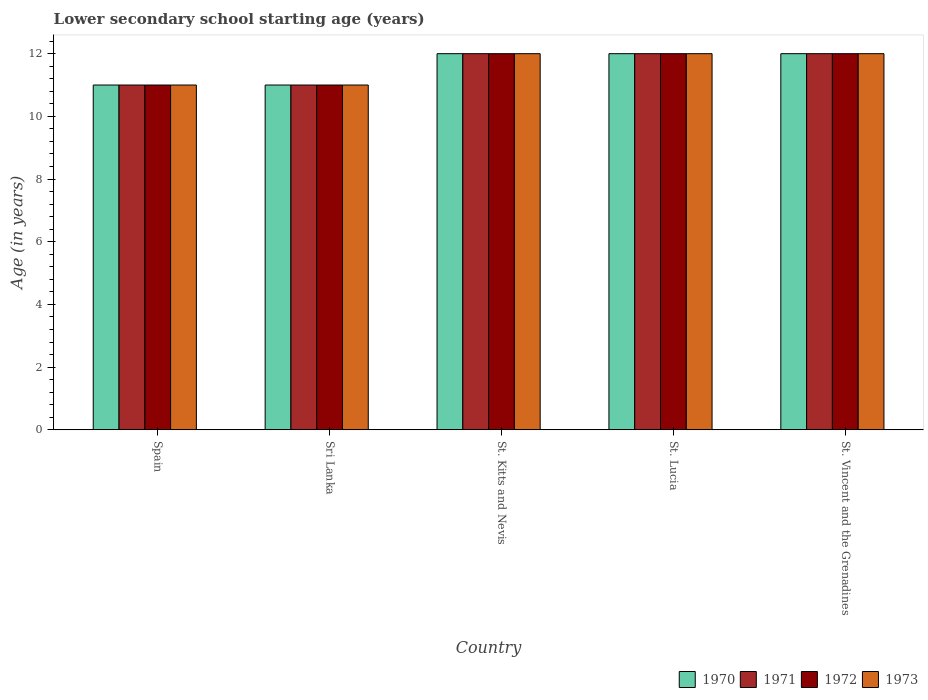How many different coloured bars are there?
Give a very brief answer. 4. How many groups of bars are there?
Offer a very short reply. 5. Are the number of bars on each tick of the X-axis equal?
Your answer should be very brief. Yes. What is the lower secondary school starting age of children in 1971 in St. Lucia?
Make the answer very short. 12. Across all countries, what is the minimum lower secondary school starting age of children in 1971?
Your answer should be very brief. 11. In which country was the lower secondary school starting age of children in 1973 maximum?
Keep it short and to the point. St. Kitts and Nevis. In which country was the lower secondary school starting age of children in 1973 minimum?
Make the answer very short. Spain. What is the difference between the lower secondary school starting age of children in 1970 in St. Kitts and Nevis and the lower secondary school starting age of children in 1971 in Sri Lanka?
Keep it short and to the point. 1. What is the average lower secondary school starting age of children in 1972 per country?
Offer a terse response. 11.6. What is the difference between the lower secondary school starting age of children of/in 1973 and lower secondary school starting age of children of/in 1971 in Spain?
Your answer should be very brief. 0. In how many countries, is the lower secondary school starting age of children in 1970 greater than 10.4 years?
Your answer should be compact. 5. What is the ratio of the lower secondary school starting age of children in 1972 in Spain to that in St. Lucia?
Provide a succinct answer. 0.92. Is the lower secondary school starting age of children in 1972 in Spain less than that in St. Kitts and Nevis?
Give a very brief answer. Yes. What is the difference between the highest and the lowest lower secondary school starting age of children in 1973?
Your response must be concise. 1. In how many countries, is the lower secondary school starting age of children in 1971 greater than the average lower secondary school starting age of children in 1971 taken over all countries?
Ensure brevity in your answer.  3. Is the sum of the lower secondary school starting age of children in 1971 in Sri Lanka and St. Lucia greater than the maximum lower secondary school starting age of children in 1973 across all countries?
Keep it short and to the point. Yes. What does the 4th bar from the right in St. Kitts and Nevis represents?
Give a very brief answer. 1970. Is it the case that in every country, the sum of the lower secondary school starting age of children in 1971 and lower secondary school starting age of children in 1972 is greater than the lower secondary school starting age of children in 1973?
Offer a very short reply. Yes. How many bars are there?
Your response must be concise. 20. Are the values on the major ticks of Y-axis written in scientific E-notation?
Make the answer very short. No. Does the graph contain any zero values?
Your answer should be compact. No. Does the graph contain grids?
Your response must be concise. No. Where does the legend appear in the graph?
Your answer should be very brief. Bottom right. What is the title of the graph?
Ensure brevity in your answer.  Lower secondary school starting age (years). Does "2013" appear as one of the legend labels in the graph?
Your answer should be compact. No. What is the label or title of the Y-axis?
Your answer should be compact. Age (in years). What is the Age (in years) of 1971 in Spain?
Give a very brief answer. 11. What is the Age (in years) of 1973 in Spain?
Offer a terse response. 11. What is the Age (in years) of 1971 in Sri Lanka?
Keep it short and to the point. 11. What is the Age (in years) of 1973 in St. Kitts and Nevis?
Your answer should be compact. 12. What is the Age (in years) of 1970 in St. Lucia?
Your response must be concise. 12. What is the Age (in years) in 1971 in St. Lucia?
Ensure brevity in your answer.  12. What is the Age (in years) in 1973 in St. Lucia?
Offer a very short reply. 12. What is the Age (in years) of 1970 in St. Vincent and the Grenadines?
Provide a short and direct response. 12. What is the Age (in years) in 1971 in St. Vincent and the Grenadines?
Ensure brevity in your answer.  12. What is the Age (in years) of 1972 in St. Vincent and the Grenadines?
Ensure brevity in your answer.  12. Across all countries, what is the maximum Age (in years) of 1972?
Offer a very short reply. 12. Across all countries, what is the maximum Age (in years) in 1973?
Offer a very short reply. 12. Across all countries, what is the minimum Age (in years) of 1971?
Your response must be concise. 11. What is the difference between the Age (in years) in 1970 in Spain and that in Sri Lanka?
Make the answer very short. 0. What is the difference between the Age (in years) of 1971 in Spain and that in Sri Lanka?
Provide a succinct answer. 0. What is the difference between the Age (in years) in 1972 in Spain and that in Sri Lanka?
Keep it short and to the point. 0. What is the difference between the Age (in years) in 1971 in Spain and that in St. Kitts and Nevis?
Provide a short and direct response. -1. What is the difference between the Age (in years) of 1972 in Spain and that in St. Kitts and Nevis?
Offer a terse response. -1. What is the difference between the Age (in years) in 1973 in Spain and that in St. Kitts and Nevis?
Your answer should be compact. -1. What is the difference between the Age (in years) of 1970 in Spain and that in St. Lucia?
Offer a terse response. -1. What is the difference between the Age (in years) of 1971 in Spain and that in St. Lucia?
Give a very brief answer. -1. What is the difference between the Age (in years) in 1972 in Spain and that in St. Lucia?
Offer a very short reply. -1. What is the difference between the Age (in years) in 1970 in Spain and that in St. Vincent and the Grenadines?
Your answer should be very brief. -1. What is the difference between the Age (in years) in 1970 in Sri Lanka and that in St. Kitts and Nevis?
Your answer should be very brief. -1. What is the difference between the Age (in years) of 1972 in Sri Lanka and that in St. Kitts and Nevis?
Make the answer very short. -1. What is the difference between the Age (in years) in 1971 in Sri Lanka and that in St. Lucia?
Offer a terse response. -1. What is the difference between the Age (in years) of 1972 in Sri Lanka and that in St. Lucia?
Your answer should be very brief. -1. What is the difference between the Age (in years) of 1971 in Sri Lanka and that in St. Vincent and the Grenadines?
Your answer should be very brief. -1. What is the difference between the Age (in years) in 1972 in Sri Lanka and that in St. Vincent and the Grenadines?
Keep it short and to the point. -1. What is the difference between the Age (in years) in 1973 in Sri Lanka and that in St. Vincent and the Grenadines?
Keep it short and to the point. -1. What is the difference between the Age (in years) of 1971 in St. Kitts and Nevis and that in St. Lucia?
Your response must be concise. 0. What is the difference between the Age (in years) of 1970 in St. Kitts and Nevis and that in St. Vincent and the Grenadines?
Provide a succinct answer. 0. What is the difference between the Age (in years) in 1971 in St. Kitts and Nevis and that in St. Vincent and the Grenadines?
Your answer should be compact. 0. What is the difference between the Age (in years) in 1972 in St. Kitts and Nevis and that in St. Vincent and the Grenadines?
Make the answer very short. 0. What is the difference between the Age (in years) of 1971 in St. Lucia and that in St. Vincent and the Grenadines?
Ensure brevity in your answer.  0. What is the difference between the Age (in years) in 1972 in St. Lucia and that in St. Vincent and the Grenadines?
Ensure brevity in your answer.  0. What is the difference between the Age (in years) of 1973 in St. Lucia and that in St. Vincent and the Grenadines?
Your answer should be compact. 0. What is the difference between the Age (in years) of 1970 in Spain and the Age (in years) of 1971 in Sri Lanka?
Keep it short and to the point. 0. What is the difference between the Age (in years) in 1970 in Spain and the Age (in years) in 1972 in Sri Lanka?
Ensure brevity in your answer.  0. What is the difference between the Age (in years) of 1970 in Spain and the Age (in years) of 1971 in St. Kitts and Nevis?
Keep it short and to the point. -1. What is the difference between the Age (in years) of 1970 in Spain and the Age (in years) of 1972 in St. Kitts and Nevis?
Give a very brief answer. -1. What is the difference between the Age (in years) of 1970 in Spain and the Age (in years) of 1973 in St. Kitts and Nevis?
Your answer should be very brief. -1. What is the difference between the Age (in years) in 1971 in Spain and the Age (in years) in 1972 in St. Kitts and Nevis?
Offer a terse response. -1. What is the difference between the Age (in years) of 1972 in Spain and the Age (in years) of 1973 in St. Kitts and Nevis?
Provide a succinct answer. -1. What is the difference between the Age (in years) of 1970 in Spain and the Age (in years) of 1972 in St. Lucia?
Provide a succinct answer. -1. What is the difference between the Age (in years) in 1971 in Spain and the Age (in years) in 1972 in St. Lucia?
Offer a terse response. -1. What is the difference between the Age (in years) in 1971 in Spain and the Age (in years) in 1973 in St. Lucia?
Give a very brief answer. -1. What is the difference between the Age (in years) in 1972 in Spain and the Age (in years) in 1973 in St. Lucia?
Keep it short and to the point. -1. What is the difference between the Age (in years) of 1970 in Spain and the Age (in years) of 1972 in St. Vincent and the Grenadines?
Offer a very short reply. -1. What is the difference between the Age (in years) in 1970 in Spain and the Age (in years) in 1973 in St. Vincent and the Grenadines?
Give a very brief answer. -1. What is the difference between the Age (in years) in 1971 in Sri Lanka and the Age (in years) in 1973 in St. Kitts and Nevis?
Offer a terse response. -1. What is the difference between the Age (in years) of 1970 in Sri Lanka and the Age (in years) of 1971 in St. Lucia?
Provide a succinct answer. -1. What is the difference between the Age (in years) in 1970 in Sri Lanka and the Age (in years) in 1972 in St. Lucia?
Provide a short and direct response. -1. What is the difference between the Age (in years) of 1971 in Sri Lanka and the Age (in years) of 1972 in St. Lucia?
Your answer should be compact. -1. What is the difference between the Age (in years) in 1970 in Sri Lanka and the Age (in years) in 1971 in St. Vincent and the Grenadines?
Your answer should be compact. -1. What is the difference between the Age (in years) of 1970 in Sri Lanka and the Age (in years) of 1973 in St. Vincent and the Grenadines?
Your answer should be compact. -1. What is the difference between the Age (in years) of 1971 in Sri Lanka and the Age (in years) of 1973 in St. Vincent and the Grenadines?
Provide a succinct answer. -1. What is the difference between the Age (in years) of 1972 in Sri Lanka and the Age (in years) of 1973 in St. Vincent and the Grenadines?
Offer a terse response. -1. What is the difference between the Age (in years) of 1970 in St. Kitts and Nevis and the Age (in years) of 1971 in St. Lucia?
Offer a terse response. 0. What is the difference between the Age (in years) of 1970 in St. Kitts and Nevis and the Age (in years) of 1972 in St. Lucia?
Give a very brief answer. 0. What is the difference between the Age (in years) in 1970 in St. Kitts and Nevis and the Age (in years) in 1973 in St. Lucia?
Ensure brevity in your answer.  0. What is the difference between the Age (in years) in 1971 in St. Kitts and Nevis and the Age (in years) in 1973 in St. Lucia?
Provide a succinct answer. 0. What is the difference between the Age (in years) in 1970 in St. Kitts and Nevis and the Age (in years) in 1971 in St. Vincent and the Grenadines?
Ensure brevity in your answer.  0. What is the difference between the Age (in years) of 1970 in St. Kitts and Nevis and the Age (in years) of 1973 in St. Vincent and the Grenadines?
Provide a succinct answer. 0. What is the difference between the Age (in years) in 1971 in St. Kitts and Nevis and the Age (in years) in 1973 in St. Vincent and the Grenadines?
Keep it short and to the point. 0. What is the difference between the Age (in years) of 1970 in St. Lucia and the Age (in years) of 1971 in St. Vincent and the Grenadines?
Ensure brevity in your answer.  0. What is the difference between the Age (in years) of 1970 in St. Lucia and the Age (in years) of 1972 in St. Vincent and the Grenadines?
Your answer should be very brief. 0. What is the difference between the Age (in years) of 1971 in St. Lucia and the Age (in years) of 1973 in St. Vincent and the Grenadines?
Provide a succinct answer. 0. What is the average Age (in years) of 1970 per country?
Keep it short and to the point. 11.6. What is the average Age (in years) in 1971 per country?
Provide a short and direct response. 11.6. What is the average Age (in years) in 1972 per country?
Your answer should be compact. 11.6. What is the average Age (in years) of 1973 per country?
Offer a very short reply. 11.6. What is the difference between the Age (in years) in 1970 and Age (in years) in 1972 in Spain?
Give a very brief answer. 0. What is the difference between the Age (in years) of 1970 and Age (in years) of 1971 in Sri Lanka?
Provide a succinct answer. 0. What is the difference between the Age (in years) of 1971 and Age (in years) of 1973 in Sri Lanka?
Your response must be concise. 0. What is the difference between the Age (in years) of 1970 and Age (in years) of 1972 in St. Kitts and Nevis?
Provide a succinct answer. 0. What is the difference between the Age (in years) of 1971 and Age (in years) of 1973 in St. Kitts and Nevis?
Offer a very short reply. 0. What is the difference between the Age (in years) in 1970 and Age (in years) in 1971 in St. Lucia?
Provide a succinct answer. 0. What is the difference between the Age (in years) of 1971 and Age (in years) of 1972 in St. Lucia?
Offer a very short reply. 0. What is the difference between the Age (in years) in 1972 and Age (in years) in 1973 in St. Lucia?
Your response must be concise. 0. What is the difference between the Age (in years) of 1972 and Age (in years) of 1973 in St. Vincent and the Grenadines?
Your response must be concise. 0. What is the ratio of the Age (in years) in 1971 in Spain to that in Sri Lanka?
Keep it short and to the point. 1. What is the ratio of the Age (in years) of 1972 in Spain to that in Sri Lanka?
Offer a terse response. 1. What is the ratio of the Age (in years) in 1970 in Spain to that in St. Kitts and Nevis?
Make the answer very short. 0.92. What is the ratio of the Age (in years) in 1971 in Spain to that in St. Kitts and Nevis?
Offer a very short reply. 0.92. What is the ratio of the Age (in years) of 1970 in Spain to that in St. Lucia?
Keep it short and to the point. 0.92. What is the ratio of the Age (in years) of 1972 in Spain to that in St. Lucia?
Your response must be concise. 0.92. What is the ratio of the Age (in years) of 1970 in Spain to that in St. Vincent and the Grenadines?
Your answer should be very brief. 0.92. What is the ratio of the Age (in years) of 1971 in Spain to that in St. Vincent and the Grenadines?
Offer a terse response. 0.92. What is the ratio of the Age (in years) of 1973 in Spain to that in St. Vincent and the Grenadines?
Offer a terse response. 0.92. What is the ratio of the Age (in years) in 1972 in Sri Lanka to that in St. Lucia?
Your answer should be compact. 0.92. What is the ratio of the Age (in years) of 1970 in Sri Lanka to that in St. Vincent and the Grenadines?
Your response must be concise. 0.92. What is the ratio of the Age (in years) of 1972 in Sri Lanka to that in St. Vincent and the Grenadines?
Make the answer very short. 0.92. What is the ratio of the Age (in years) in 1973 in Sri Lanka to that in St. Vincent and the Grenadines?
Provide a succinct answer. 0.92. What is the ratio of the Age (in years) of 1970 in St. Kitts and Nevis to that in St. Lucia?
Your answer should be compact. 1. What is the ratio of the Age (in years) in 1971 in St. Kitts and Nevis to that in St. Lucia?
Offer a very short reply. 1. What is the ratio of the Age (in years) of 1973 in St. Kitts and Nevis to that in St. Lucia?
Offer a very short reply. 1. What is the ratio of the Age (in years) in 1970 in St. Kitts and Nevis to that in St. Vincent and the Grenadines?
Keep it short and to the point. 1. What is the ratio of the Age (in years) in 1972 in St. Kitts and Nevis to that in St. Vincent and the Grenadines?
Your response must be concise. 1. What is the ratio of the Age (in years) of 1973 in St. Kitts and Nevis to that in St. Vincent and the Grenadines?
Offer a very short reply. 1. What is the ratio of the Age (in years) in 1970 in St. Lucia to that in St. Vincent and the Grenadines?
Offer a terse response. 1. What is the ratio of the Age (in years) in 1973 in St. Lucia to that in St. Vincent and the Grenadines?
Your answer should be compact. 1. What is the difference between the highest and the second highest Age (in years) of 1971?
Your answer should be very brief. 0. What is the difference between the highest and the second highest Age (in years) of 1972?
Ensure brevity in your answer.  0. What is the difference between the highest and the second highest Age (in years) in 1973?
Ensure brevity in your answer.  0. What is the difference between the highest and the lowest Age (in years) of 1970?
Keep it short and to the point. 1. What is the difference between the highest and the lowest Age (in years) of 1971?
Your answer should be compact. 1. What is the difference between the highest and the lowest Age (in years) of 1972?
Make the answer very short. 1. 